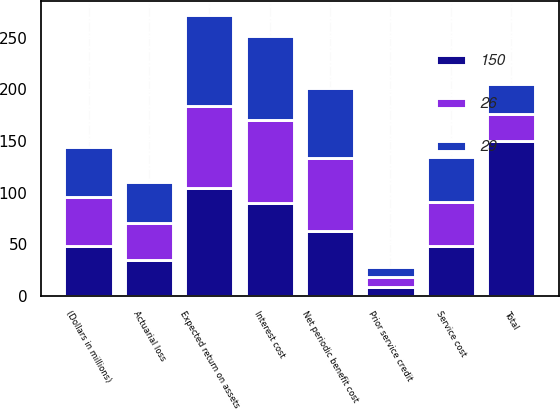<chart> <loc_0><loc_0><loc_500><loc_500><stacked_bar_chart><ecel><fcel>(Dollars in millions)<fcel>Service cost<fcel>Interest cost<fcel>Expected return on assets<fcel>Prior service credit<fcel>Actuarial loss<fcel>Net periodic benefit cost<fcel>Total<nl><fcel>150<fcel>48<fcel>48<fcel>90<fcel>105<fcel>9<fcel>35<fcel>63<fcel>150<nl><fcel>29<fcel>48<fcel>44<fcel>82<fcel>88<fcel>10<fcel>39<fcel>67<fcel>29<nl><fcel>26<fcel>48<fcel>43<fcel>80<fcel>79<fcel>9<fcel>36<fcel>71<fcel>26<nl></chart> 